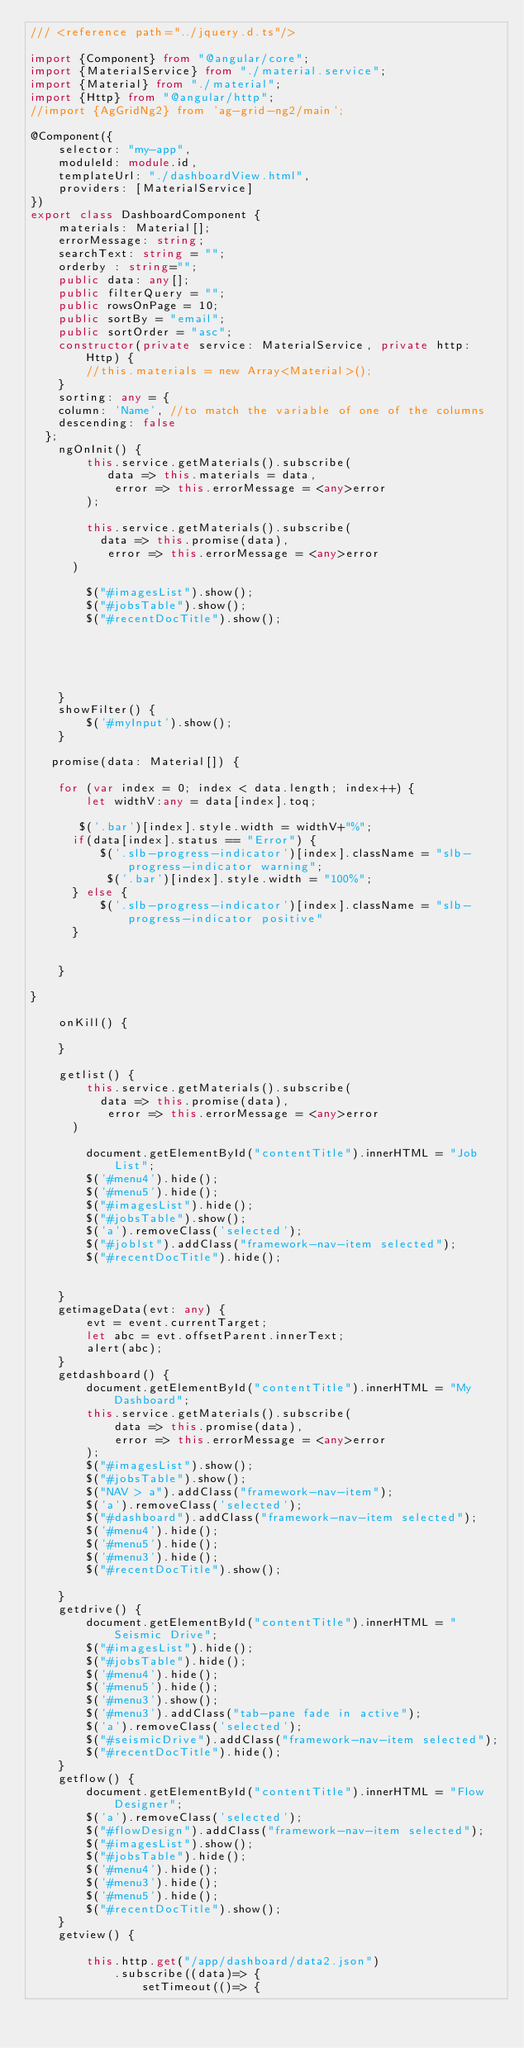<code> <loc_0><loc_0><loc_500><loc_500><_TypeScript_>/// <reference path="../jquery.d.ts"/>

import {Component} from "@angular/core";
import {MaterialService} from "./material.service";
import {Material} from "./material";
import {Http} from "@angular/http";
//import {AgGridNg2} from 'ag-grid-ng2/main';

@Component({
    selector: "my-app",
    moduleId: module.id,
    templateUrl: "./dashboardView.html",
    providers: [MaterialService]
})
export class DashboardComponent {
    materials: Material[];
    errorMessage: string;
    searchText: string = "";
    orderby : string="";
    public data: any[];
    public filterQuery = "";
    public rowsOnPage = 10;
    public sortBy = "email";
    public sortOrder = "asc";
    constructor(private service: MaterialService, private http: Http) {
        //this.materials = new Array<Material>();
    }
    sorting: any = {
    column: 'Name', //to match the variable of one of the columns
    descending: false
  };
    ngOnInit() {
        this.service.getMaterials().subscribe(
           data => this.materials = data,
            error => this.errorMessage = <any>error
        );

        this.service.getMaterials().subscribe(
          data => this.promise(data),
           error => this.errorMessage = <any>error
      )
        
        $("#imagesList").show();
        $("#jobsTable").show();
        $("#recentDocTitle").show();

        



    }
    showFilter() {
        $('#myInput').show();
    }

   promise(data: Material[]) {
    
    for (var index = 0; index < data.length; index++) {
        let widthV:any = data[index].toq;
       
       $('.bar')[index].style.width = widthV+"%";
      if(data[index].status == "Error") {
          $('.slb-progress-indicator')[index].className = "slb-progress-indicator warning";
           $('.bar')[index].style.width = "100%";
      } else {
          $('.slb-progress-indicator')[index].className = "slb-progress-indicator positive"
      }
       
        
    }
    
}

    onKill() {
       
    }

    getlist() {
        this.service.getMaterials().subscribe(
          data => this.promise(data),
           error => this.errorMessage = <any>error
      )

        document.getElementById("contentTitle").innerHTML = "Job List";
        $('#menu4').hide();
        $('#menu5').hide();
        $("#imagesList").hide();
        $("#jobsTable").show();
        $('a').removeClass('selected');
        $("#joblst").addClass("framework-nav-item selected");
        $("#recentDocTitle").hide();


    }
    getimageData(evt: any) {
        evt = event.currentTarget;
        let abc = evt.offsetParent.innerText;
        alert(abc);
    }
    getdashboard() {
        document.getElementById("contentTitle").innerHTML = "My Dashboard";
        this.service.getMaterials().subscribe(
            data => this.promise(data),
            error => this.errorMessage = <any>error
        );
        $("#imagesList").show();
        $("#jobsTable").show();
        $("NAV > a").addClass("framework-nav-item");
        $('a').removeClass('selected');
        $("#dashboard").addClass("framework-nav-item selected");
        $('#menu4').hide();
        $('#menu5').hide();
        $('#menu3').hide();
        $("#recentDocTitle").show();

    }
    getdrive() {
        document.getElementById("contentTitle").innerHTML = "Seismic Drive";
        $("#imagesList").hide();
        $("#jobsTable").hide();
        $('#menu4').hide();
        $('#menu5').hide();
        $('#menu3').show();
        $('#menu3').addClass("tab-pane fade in active");
        $('a').removeClass('selected');
        $("#seismicDrive").addClass("framework-nav-item selected");
        $("#recentDocTitle").hide();
    }
    getflow() {
        document.getElementById("contentTitle").innerHTML = "Flow Designer";
        $('a').removeClass('selected');
        $("#flowDesign").addClass("framework-nav-item selected");
        $("#imagesList").show();
        $("#jobsTable").hide();
        $('#menu4').hide();
        $('#menu3').hide();
        $('#menu5').hide();
        $("#recentDocTitle").show();
    }
    getview() {

        this.http.get("/app/dashboard/data2.json")
            .subscribe((data)=> {
                setTimeout(()=> {</code> 